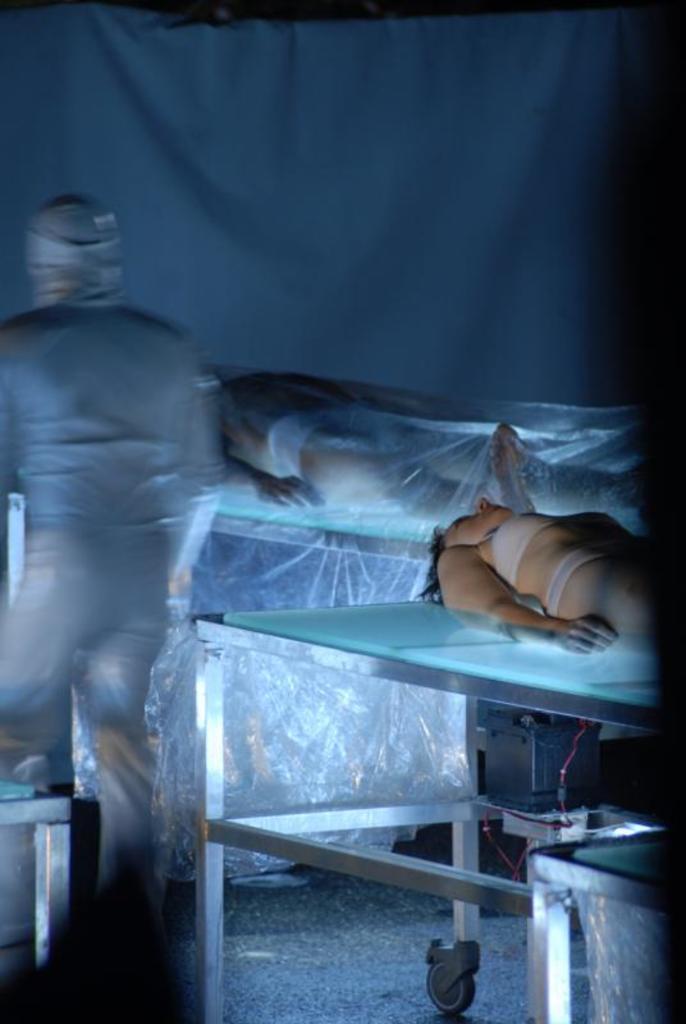Please provide a concise description of this image. On the right side there are humans sleeping on the glass tables. 